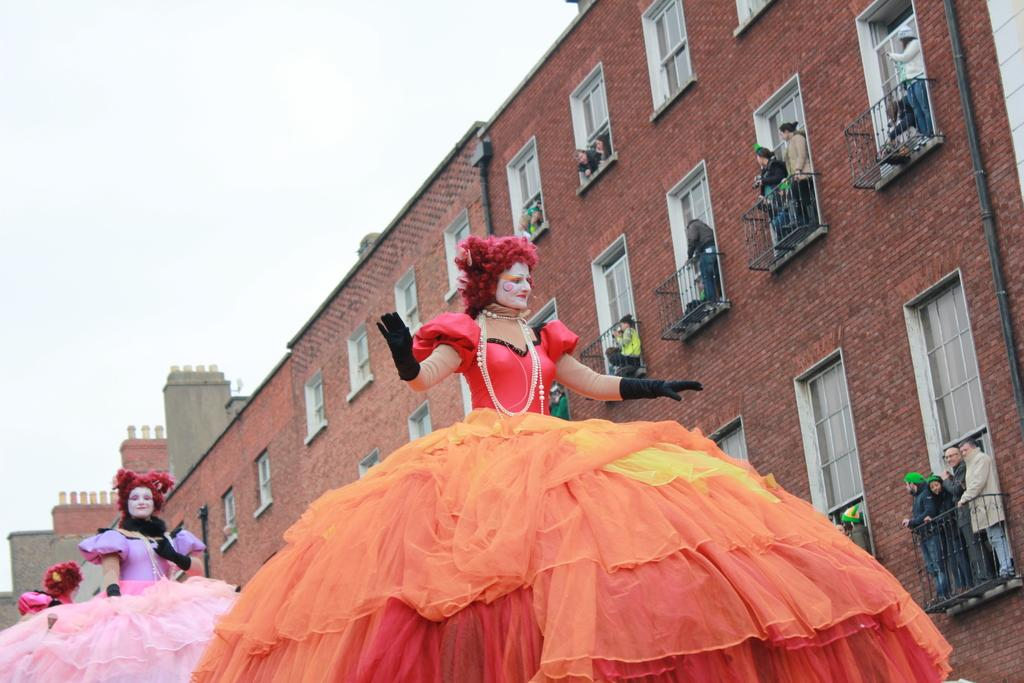How many people are in the image? There are persons in the image, but the exact number cannot be determined from the provided facts. What can be seen in the background of the image? There are buildings and the sky visible in the background of the image. What type of eggnog is being served in the image? There is no eggnog present in the image. How does the shock affect the persons in the image? There is no shock present in the image, so it cannot affect the persons. 